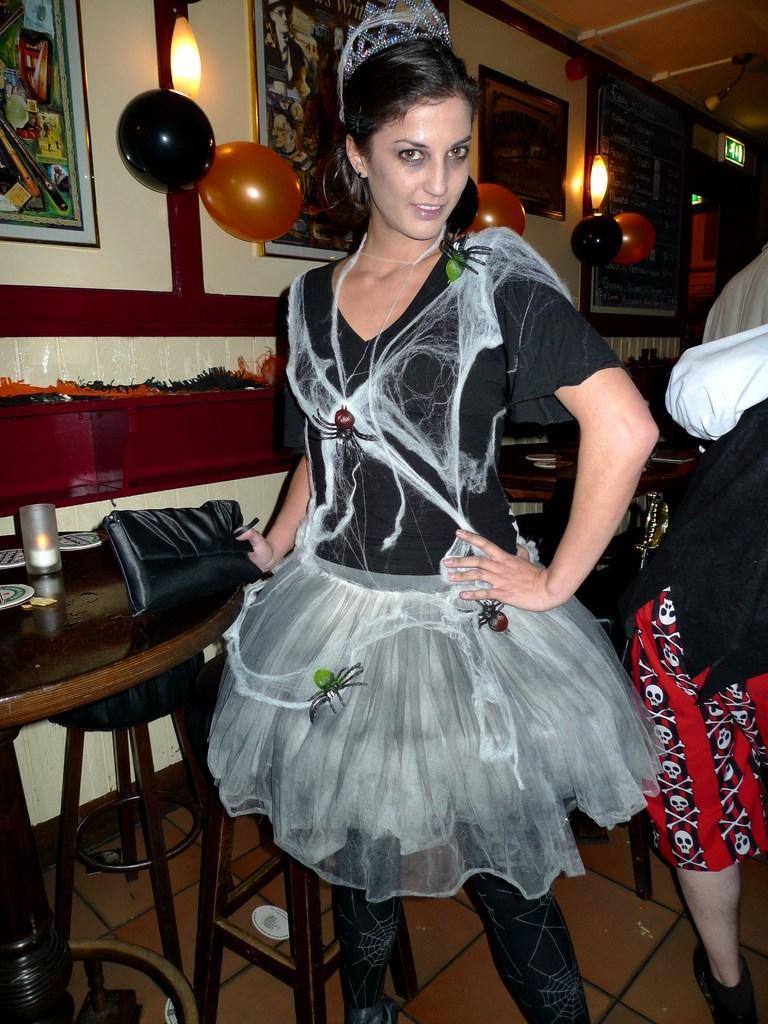How would you summarize this image in a sentence or two? In this picture these persons standing. This is floor. We can see table and chairs. On the table we can see bag,cup. On the background we can see wall,posters,light,balloons. This person holding wallet. 